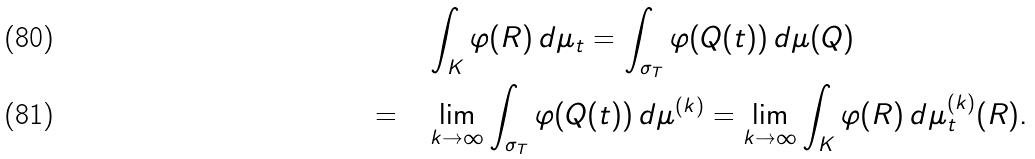<formula> <loc_0><loc_0><loc_500><loc_500>& \quad \int _ { K } \varphi ( R ) \, d \mu _ { t } = \int _ { \sigma _ { T } } \varphi ( Q ( t ) ) \, d \mu ( Q ) \\ = & \quad \lim _ { k \rightarrow \infty } \int _ { \sigma _ { T } } \varphi ( Q ( t ) ) \, d \mu ^ { ( k ) } = \lim _ { k \rightarrow \infty } \int _ { K } \varphi ( R ) \, d \mu ^ { ( k ) } _ { t } ( R ) .</formula> 